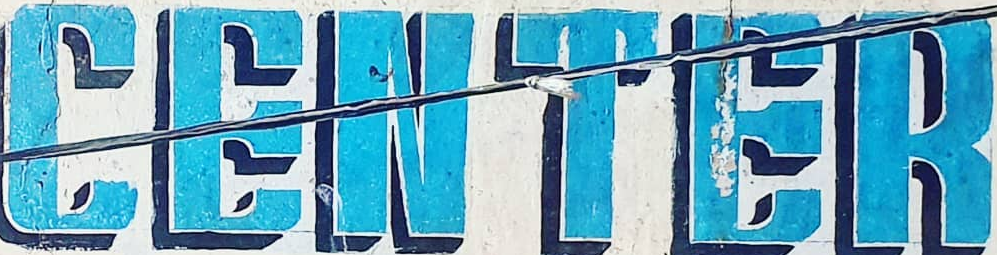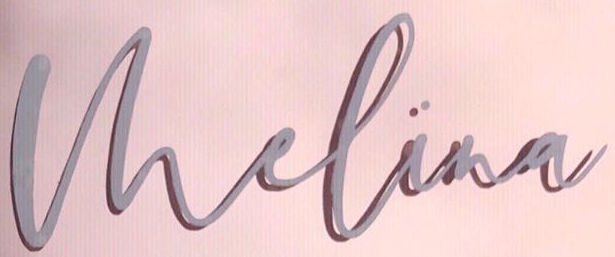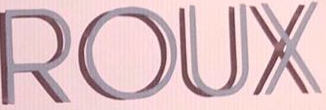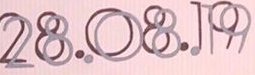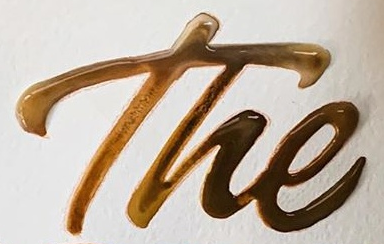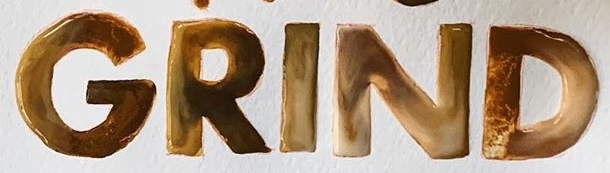Read the text from these images in sequence, separated by a semicolon. CENTER; Vhelina; ROUX; 28.08.19; The; GRIND 